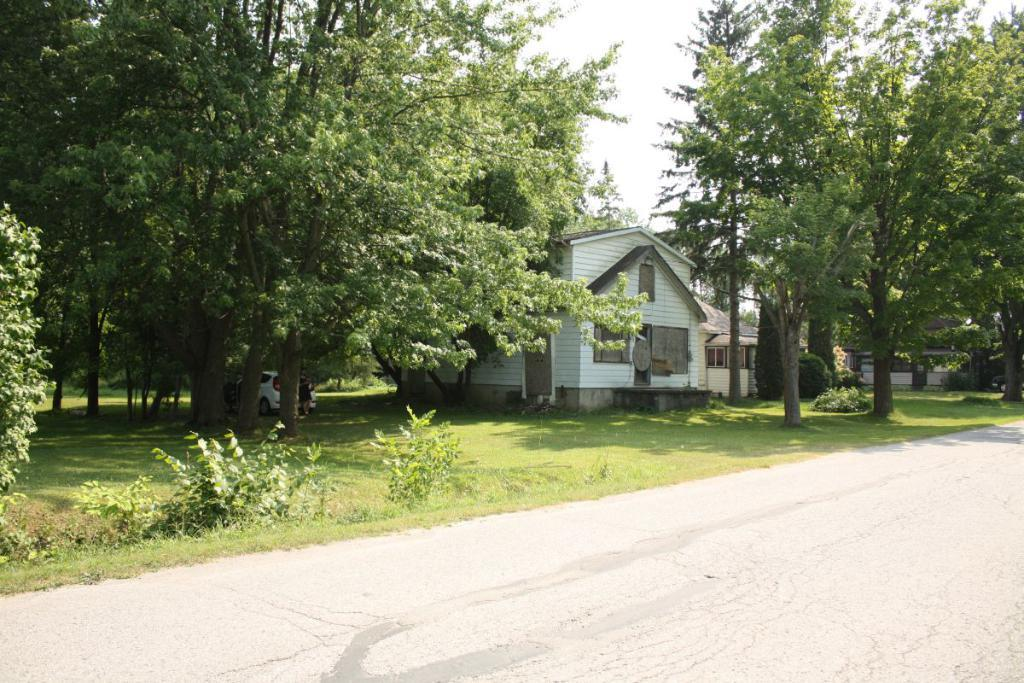What type of vegetation can be seen in the image? There are trees in the image. What type of structures are present in the image? There are houses in the image. What architectural feature is visible in the houses? There are windows in the image. What mode of transportation can be seen in the image? There is a vehicle in the image. What type of ground cover is present in the image? There is grass in the image. What is the color of the sky in the image? The sky is white in color. Where is the store located in the image? There is no store present in the image. How many birds are in the flock in the image? There is no flock of birds present in the image. 